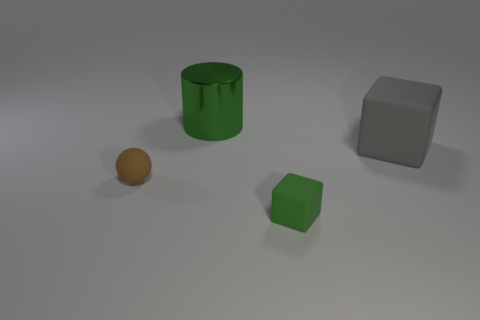Are there any other things that are the same shape as the brown object?
Make the answer very short. No. How many brown objects are either balls or large blocks?
Offer a terse response. 1. What number of matte objects are either small blocks or tiny brown things?
Your answer should be very brief. 2. Is there a purple matte object?
Keep it short and to the point. No. Do the big gray thing and the small green matte object have the same shape?
Provide a short and direct response. Yes. How many small brown spheres are in front of the matte cube that is in front of the cube behind the tiny green matte thing?
Ensure brevity in your answer.  0. There is a thing that is behind the brown object and to the left of the large gray block; what is its material?
Your answer should be very brief. Metal. What color is the thing that is left of the large cube and behind the ball?
Provide a succinct answer. Green. Are there any other things that are the same color as the big rubber block?
Your answer should be compact. No. What shape is the thing on the left side of the green object behind the big object that is in front of the green metallic cylinder?
Offer a very short reply. Sphere. 